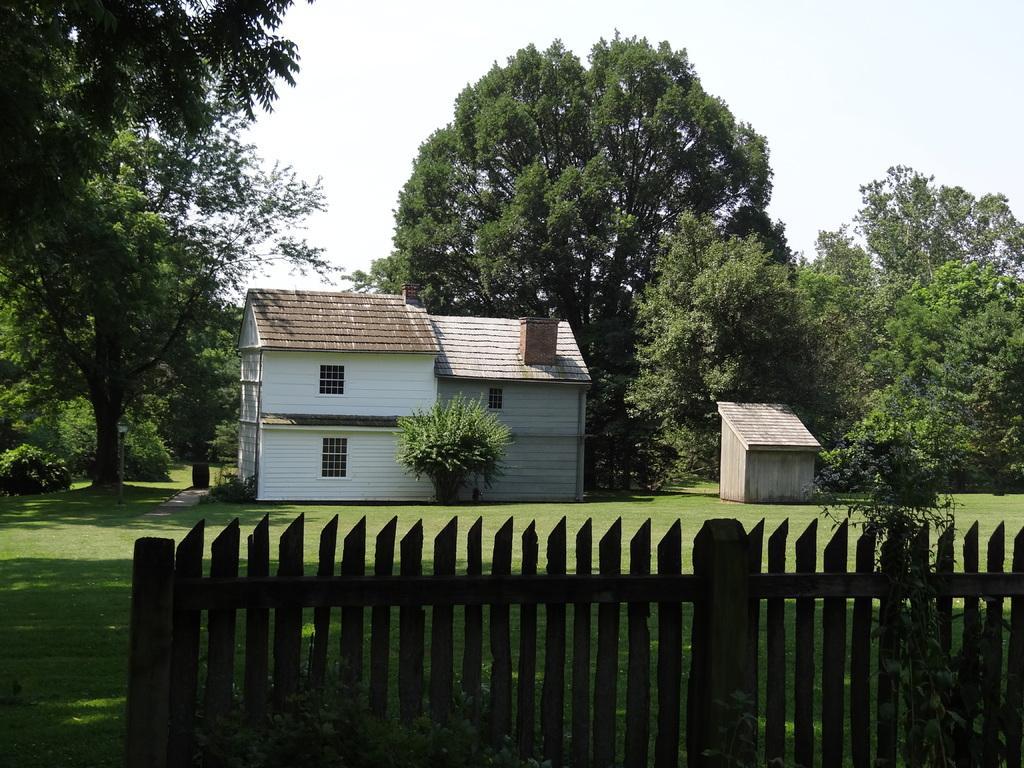Can you describe this image briefly? In this image in the foreground there is wooden fence. In the background there is a building and a hut. There are trees in the back. The sky is clear. 